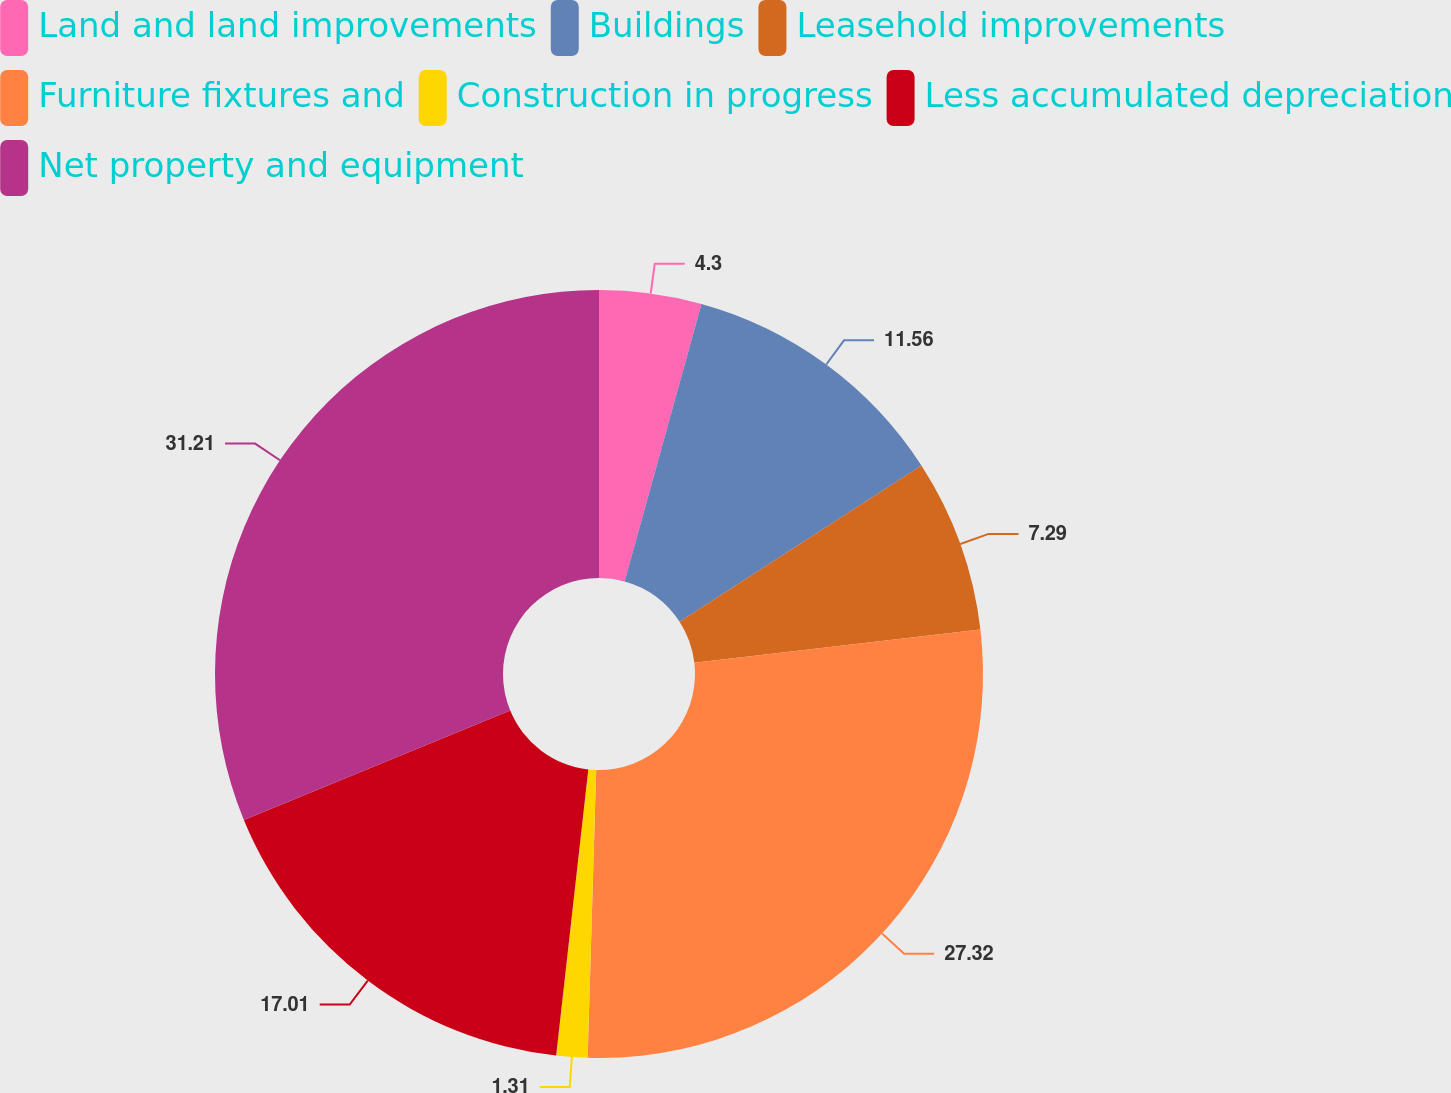Convert chart. <chart><loc_0><loc_0><loc_500><loc_500><pie_chart><fcel>Land and land improvements<fcel>Buildings<fcel>Leasehold improvements<fcel>Furniture fixtures and<fcel>Construction in progress<fcel>Less accumulated depreciation<fcel>Net property and equipment<nl><fcel>4.3%<fcel>11.56%<fcel>7.29%<fcel>27.32%<fcel>1.31%<fcel>17.01%<fcel>31.21%<nl></chart> 